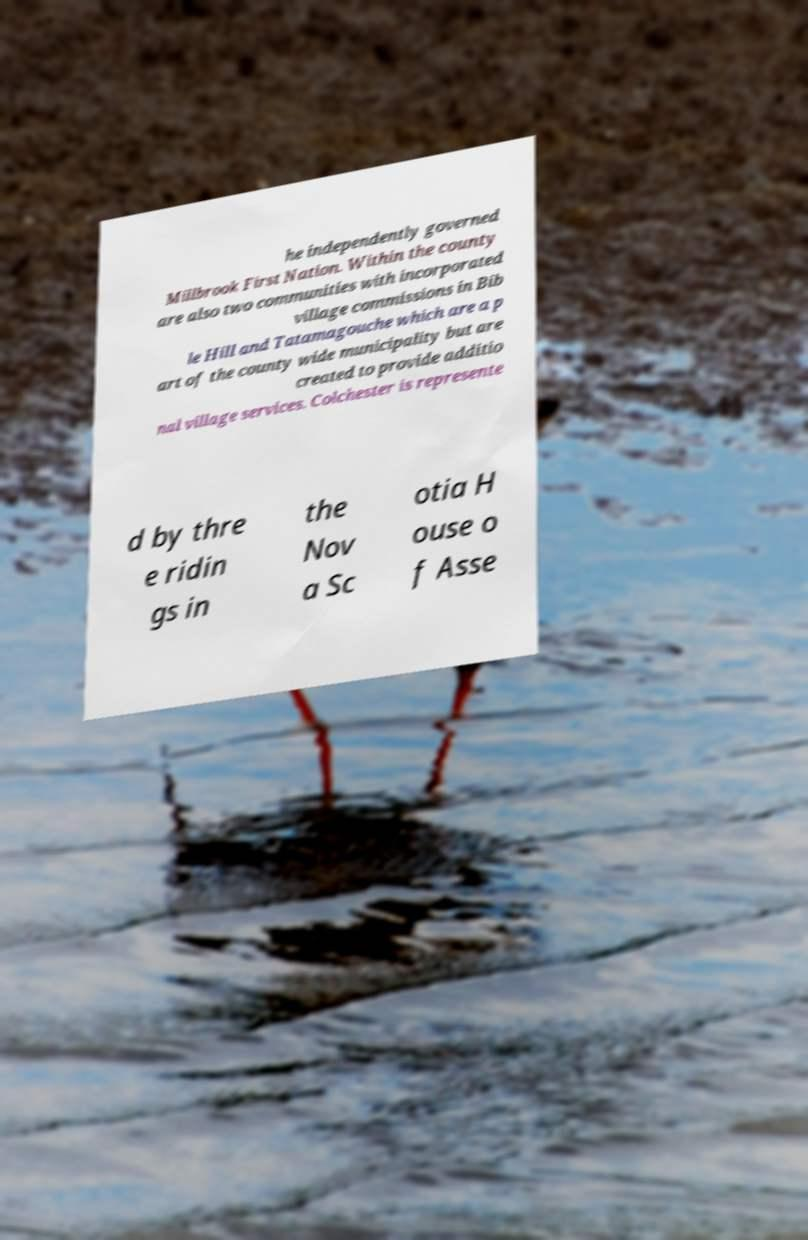Can you read and provide the text displayed in the image?This photo seems to have some interesting text. Can you extract and type it out for me? he independently governed Millbrook First Nation. Within the county are also two communities with incorporated village commissions in Bib le Hill and Tatamagouche which are a p art of the county wide municipality but are created to provide additio nal village services. Colchester is represente d by thre e ridin gs in the Nov a Sc otia H ouse o f Asse 